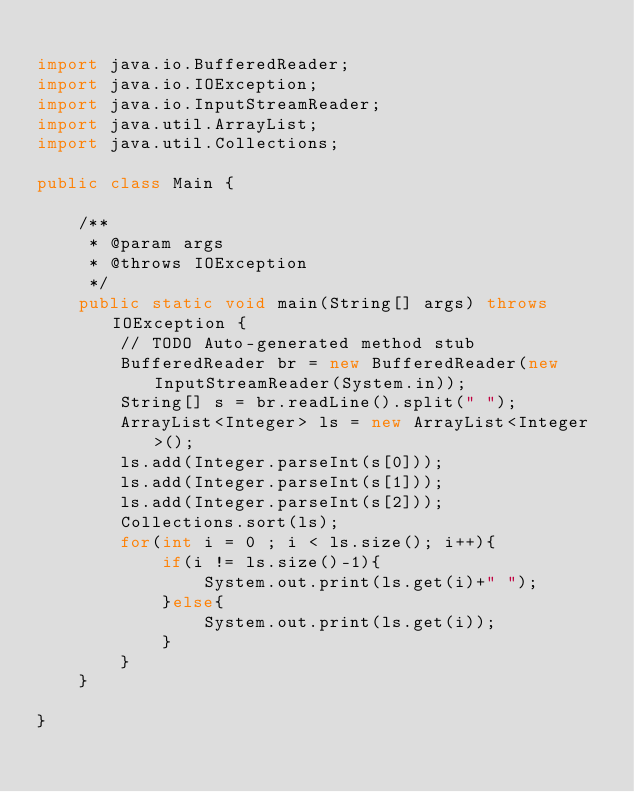Convert code to text. <code><loc_0><loc_0><loc_500><loc_500><_Java_>
import java.io.BufferedReader;
import java.io.IOException;
import java.io.InputStreamReader;
import java.util.ArrayList;
import java.util.Collections;

public class Main {

	/**
	 * @param args
	 * @throws IOException 
	 */
	public static void main(String[] args) throws IOException {
		// TODO Auto-generated method stub
		BufferedReader br = new BufferedReader(new InputStreamReader(System.in));
		String[] s = br.readLine().split(" ");
		ArrayList<Integer> ls = new ArrayList<Integer>();
		ls.add(Integer.parseInt(s[0]));
		ls.add(Integer.parseInt(s[1]));
		ls.add(Integer.parseInt(s[2]));
		Collections.sort(ls);
		for(int i = 0 ; i < ls.size(); i++){
			if(i != ls.size()-1){
				System.out.print(ls.get(i)+" ");
			}else{
				System.out.print(ls.get(i));
			}
		}
	}

}</code> 